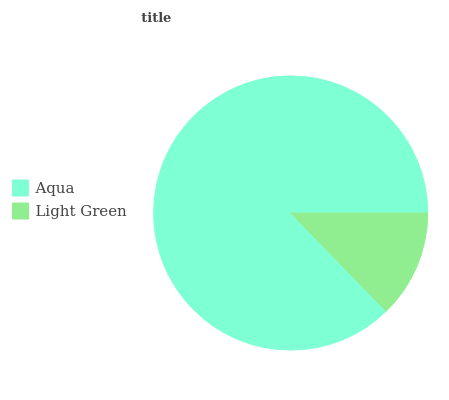Is Light Green the minimum?
Answer yes or no. Yes. Is Aqua the maximum?
Answer yes or no. Yes. Is Light Green the maximum?
Answer yes or no. No. Is Aqua greater than Light Green?
Answer yes or no. Yes. Is Light Green less than Aqua?
Answer yes or no. Yes. Is Light Green greater than Aqua?
Answer yes or no. No. Is Aqua less than Light Green?
Answer yes or no. No. Is Aqua the high median?
Answer yes or no. Yes. Is Light Green the low median?
Answer yes or no. Yes. Is Light Green the high median?
Answer yes or no. No. Is Aqua the low median?
Answer yes or no. No. 